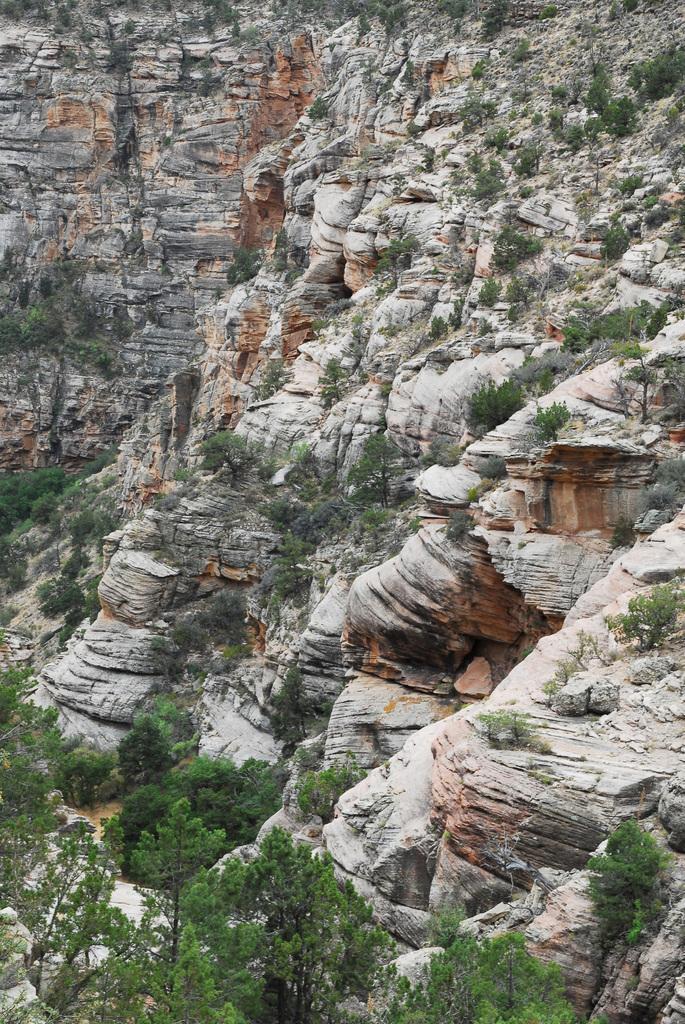How would you summarize this image in a sentence or two? This image is taken outdoors. In this image there are many rocks and there are many trees and plants. 